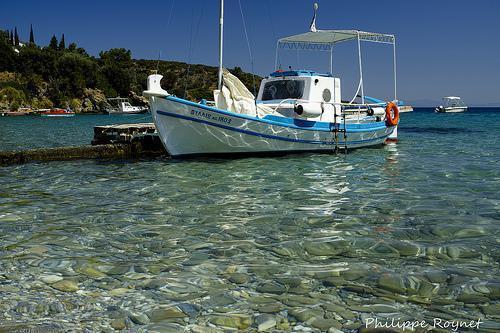How many boats in this image?
Give a very brief answer. 4. 